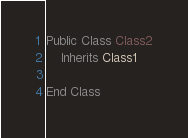<code> <loc_0><loc_0><loc_500><loc_500><_VisualBasic_>
Public Class Class2
    Inherits Class1

End Class

</code> 